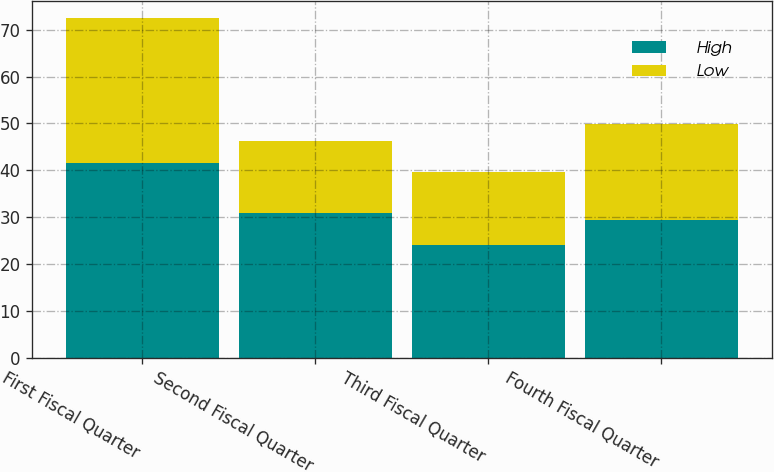<chart> <loc_0><loc_0><loc_500><loc_500><stacked_bar_chart><ecel><fcel>First Fiscal Quarter<fcel>Second Fiscal Quarter<fcel>Third Fiscal Quarter<fcel>Fourth Fiscal Quarter<nl><fcel>High<fcel>41.54<fcel>31<fcel>24.11<fcel>29.45<nl><fcel>Low<fcel>30.92<fcel>15.19<fcel>15.54<fcel>20.34<nl></chart> 